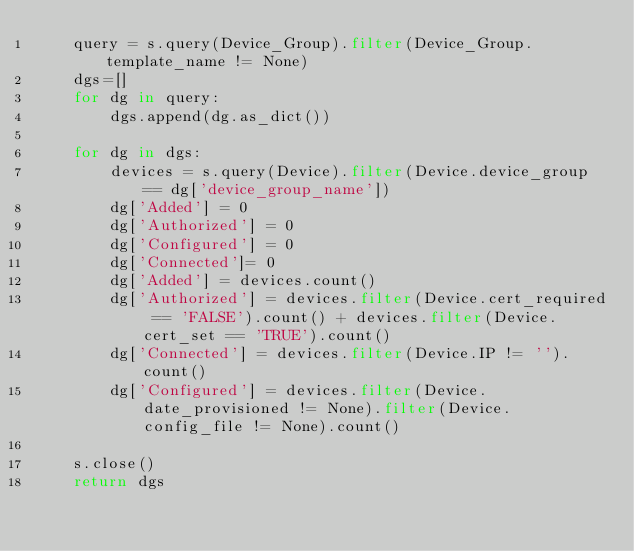Convert code to text. <code><loc_0><loc_0><loc_500><loc_500><_Python_>    query = s.query(Device_Group).filter(Device_Group.template_name != None)
    dgs=[]
    for dg in query:
        dgs.append(dg.as_dict())

    for dg in dgs:
        devices = s.query(Device).filter(Device.device_group == dg['device_group_name'])
        dg['Added'] = 0
        dg['Authorized'] = 0
        dg['Configured'] = 0
        dg['Connected']= 0
        dg['Added'] = devices.count()
        dg['Authorized'] = devices.filter(Device.cert_required == 'FALSE').count() + devices.filter(Device.cert_set == 'TRUE').count()
        dg['Connected'] = devices.filter(Device.IP != '').count()
        dg['Configured'] = devices.filter(Device.date_provisioned != None).filter(Device.config_file != None).count()

    s.close()
    return dgs
</code> 